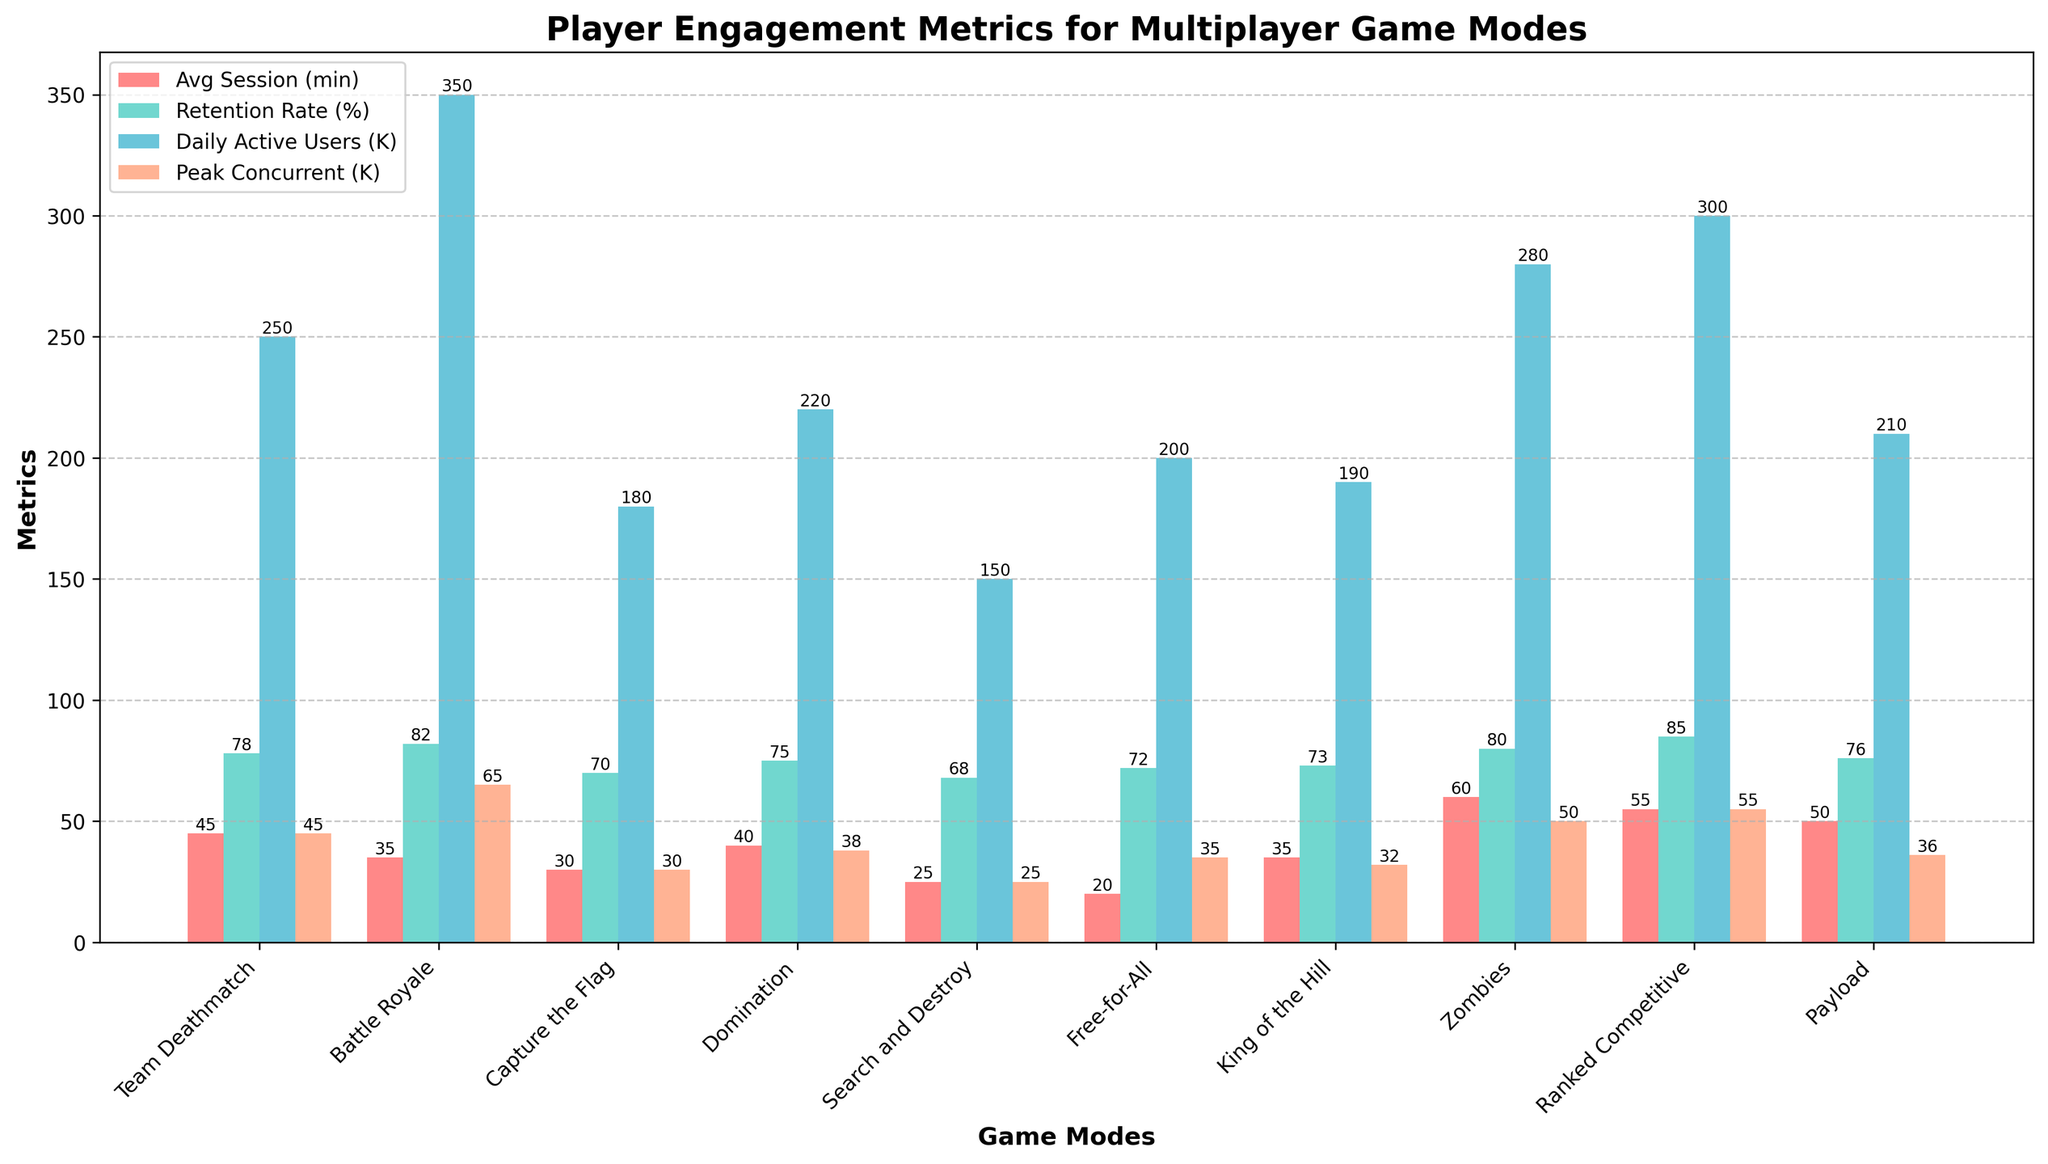What's the game mode with the highest average session duration? The figure shows bars for different game modes and their corresponding average session durations. The mode with the tallest red bar indicates the highest average session duration.
Answer: Zombies Which game mode has the lowest player retention rate? The mode with the shortest teal bar represents the lowest player retention rate.
Answer: Search and Destroy How does the daily active user count of Battle Royale compare to that of Zombies? Look at the height of the blue bars for both Battle Royale and Zombies. Battle Royale's blue bar is higher than Zombies'.
Answer: Battle Royale has more daily active users Calculate the average peak concurrent players for Team Deathmatch and Payload. Refer to the peach-colored bars for Team Deathmatch and Payload, add the values, and divide by 2: (45 + 36) / 2.
Answer: 40.5 What's the difference in daily active users between Ranked Competitive and Free-for-All? Find the blue bars for both modes, subtract the smaller value from the larger: 300 - 200 = 100 (in thousands).
Answer: 100,000 Which game mode has the highest player retention rate, and what is that percentage? Identify the tallest teal bar.
Answer: Ranked Competitive, 85% Compare the average session duration of Capture the Flag and King of the Hill. Which one is longer? Look at the red bars for both Capture the Flag and King of the Hill. King of the Hill's bar is taller.
Answer: King of the Hill What is the total daily active user count across all modes? Sum all the values of the blue bars representing daily active users: 250 + 350 + 180 + 220 + 150 + 200 + 190 + 280 + 300 + 210 = 2330 (in thousands).
Answer: 2,330,000 Identify the game mode with the second highest peak concurrent players. Find the second tallest peach-colored bar after identifying the tallest one. The tallest is Battle Royale at 65, followed by Ranked Competitive at 55.
Answer: Ranked Competitive 